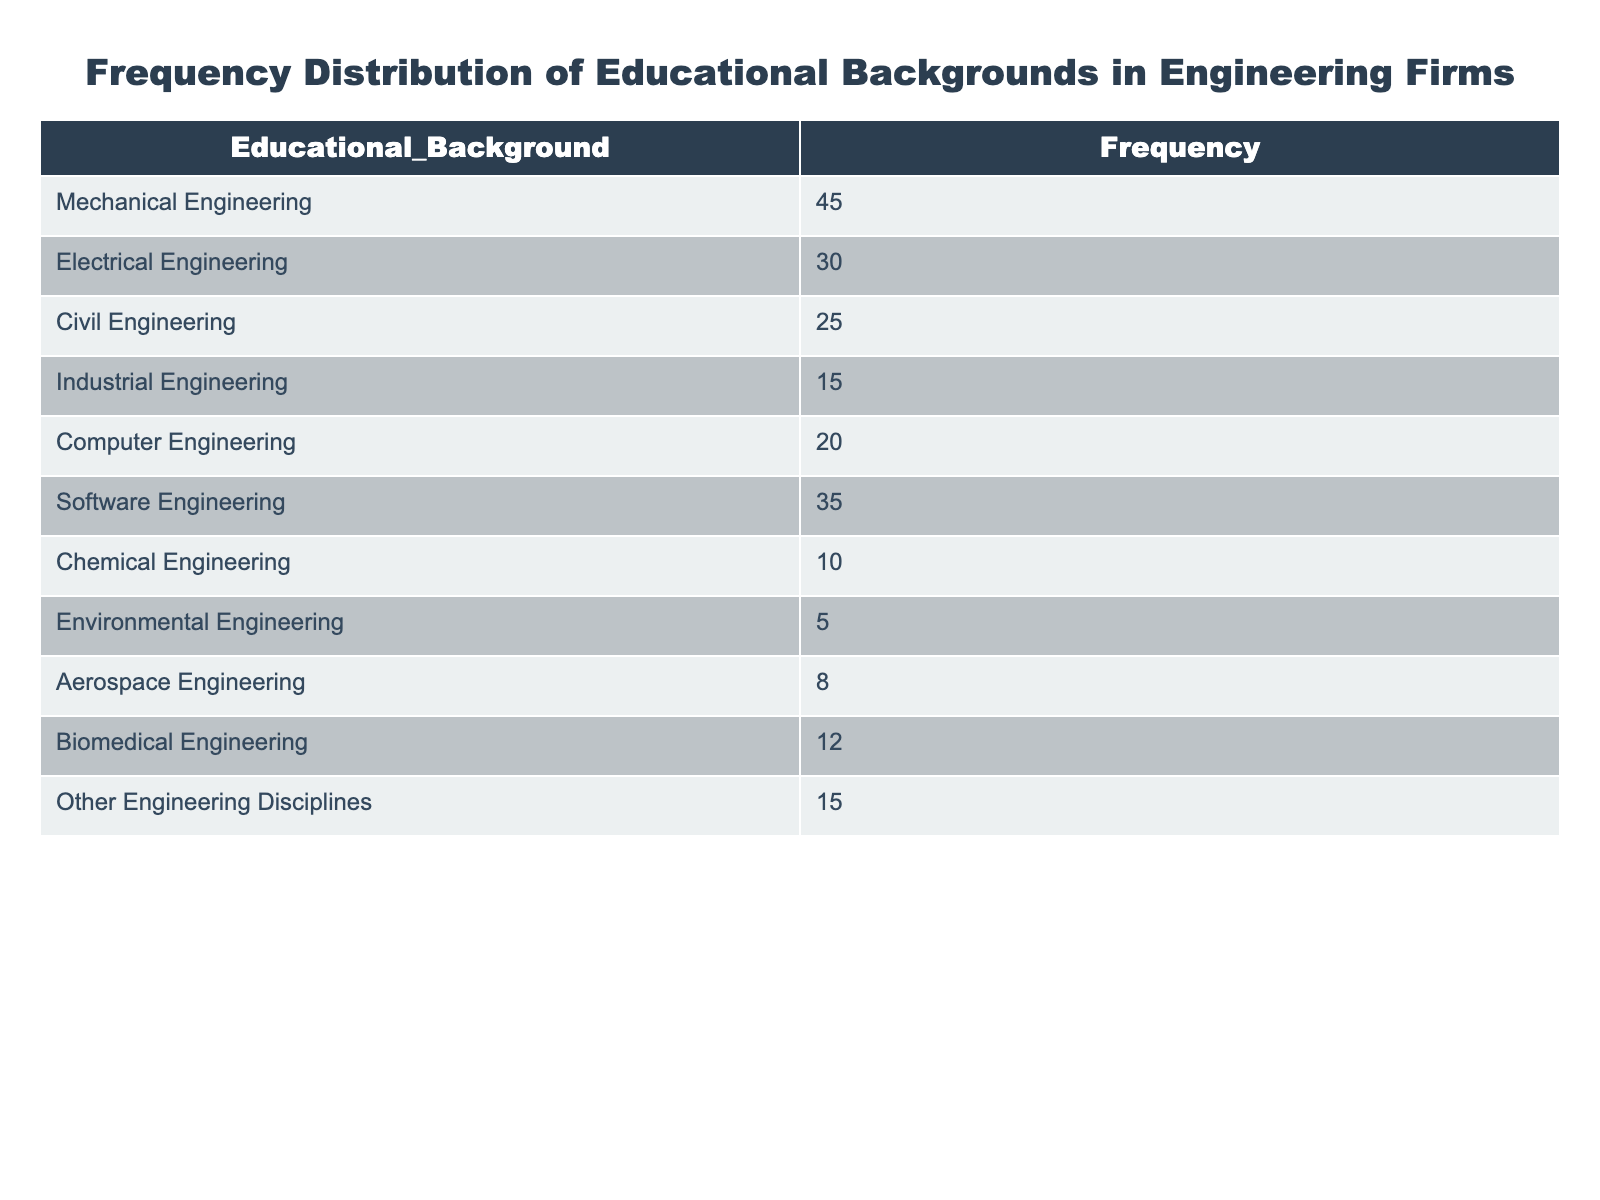What is the most common educational background among new hires? The table lists the frequencies of various educational backgrounds. The highest frequency is in Mechanical Engineering with 45 new hires.
Answer: Mechanical Engineering How many new hires have a background in Computer Engineering? The table shows that the frequency for Computer Engineering is 20 new hires.
Answer: 20 Which educational background has the fewest new hires? Looking at the frequencies, Environmental Engineering has the lowest count with 5 new hires.
Answer: Environmental Engineering What is the total number of new hires listed in the table? To find the total new hires, we sum the frequencies: 45 + 30 + 25 + 15 + 20 + 35 + 10 + 5 + 8 + 12 + 15 =  315.
Answer: 315 Is the number of Software Engineering hires greater than the number of Biomedical Engineering hires? Software Engineering has 35 new hires, while Biomedical Engineering has 12. Since 35 is greater than 12, the answer is yes.
Answer: Yes What is the combined total of new hires from Industrial Engineering and Chemical Engineering? Industrial Engineering has 15 new hires and Chemical Engineering has 10. Adding these gives 15 + 10 = 25.
Answer: 25 Are the frequencies of Electrical Engineering and Civil Engineering combined greater than the frequency of Mechanical Engineering? Electrical Engineering has 30 new hires and Civil Engineering has 25. Adding these gives 30 + 25 = 55, which is greater than the frequency of Mechanical Engineering at 45.
Answer: Yes What percentage of new hires have a background in Software Engineering? The total number of new hires is 315. Software Engineering has 35 new hires. The percentage is calculated as (35 / 315) * 100 = 11.11%.
Answer: 11.11% What is the average number of new hires across all engineering disciplines? To find the average, we add all the frequencies (315) and divide by the number of disciplines (11). 315 / 11 = approximately 28.64.
Answer: 28.64 